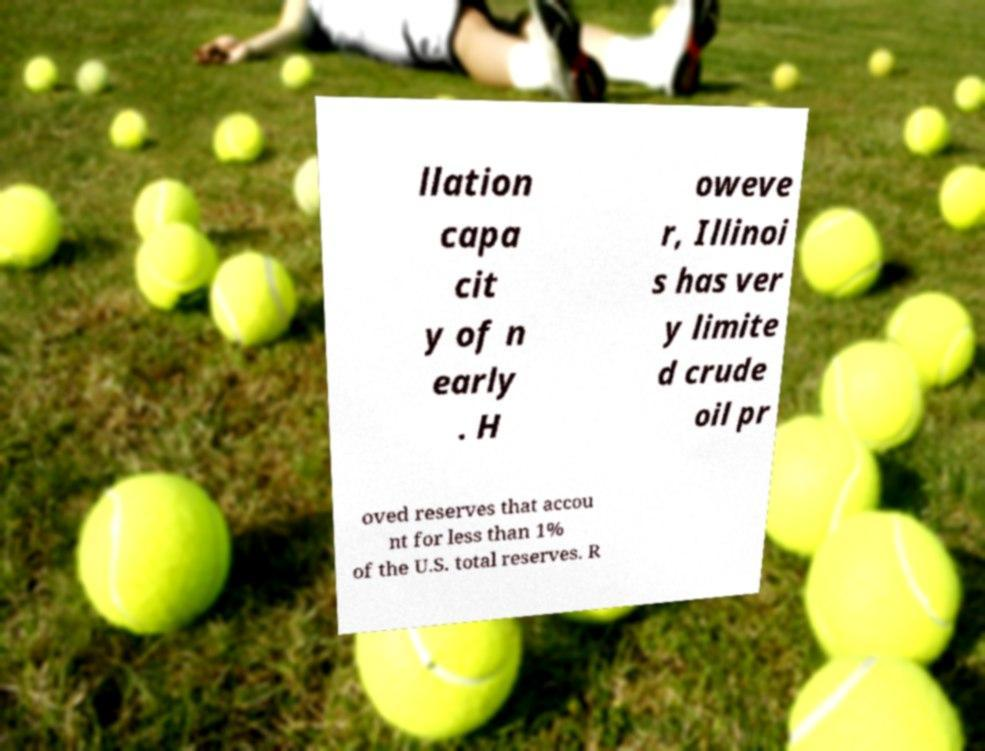I need the written content from this picture converted into text. Can you do that? llation capa cit y of n early . H oweve r, Illinoi s has ver y limite d crude oil pr oved reserves that accou nt for less than 1% of the U.S. total reserves. R 